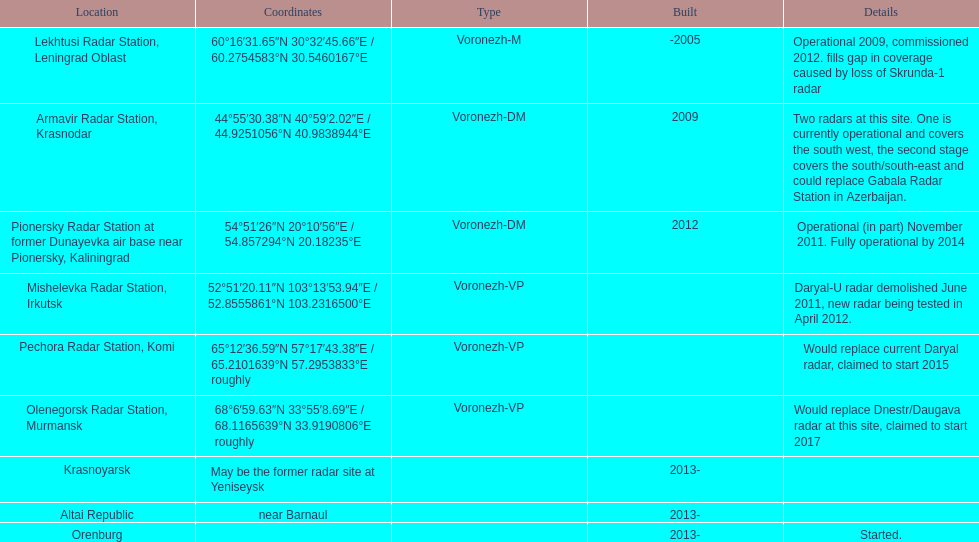When was the top created in terms of year? -2005. 